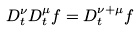Convert formula to latex. <formula><loc_0><loc_0><loc_500><loc_500>D ^ { \nu } _ { t } D ^ { \mu } _ { t } f = D ^ { \nu + \mu } _ { t } f</formula> 